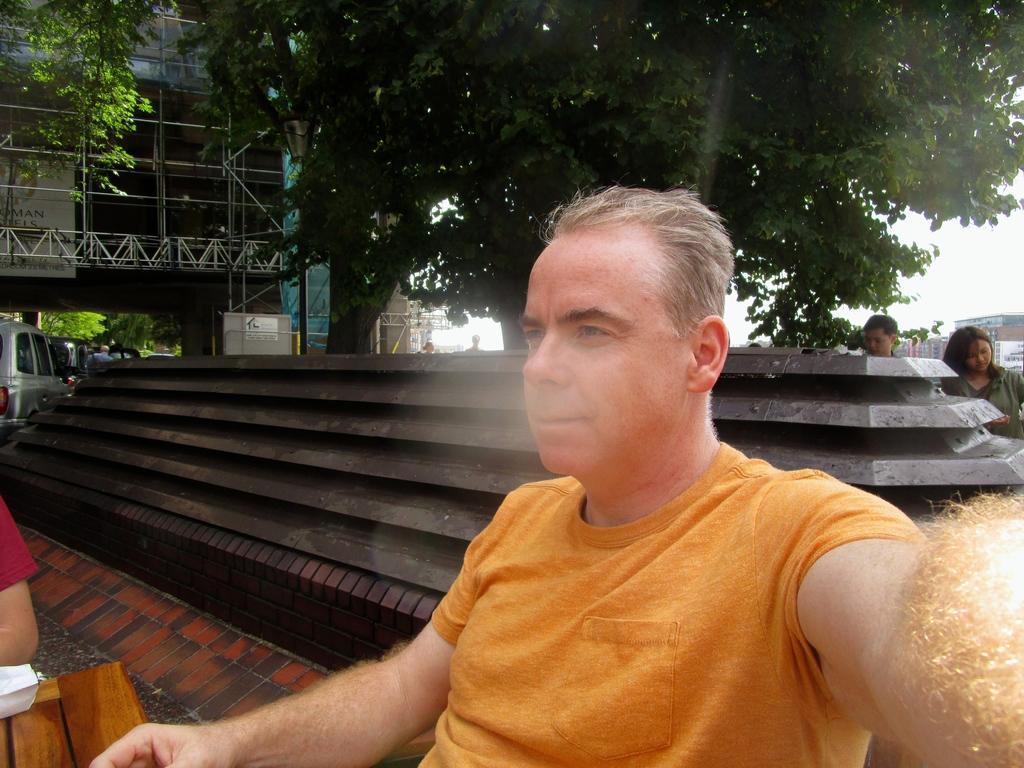Could you give a brief overview of what you see in this image? In this image we can see a man is sitting. He is wearing orange color t-shirt. Behind him some cement structure, trees and buildings are there. Left side of the image one car is there and one more person is present. 